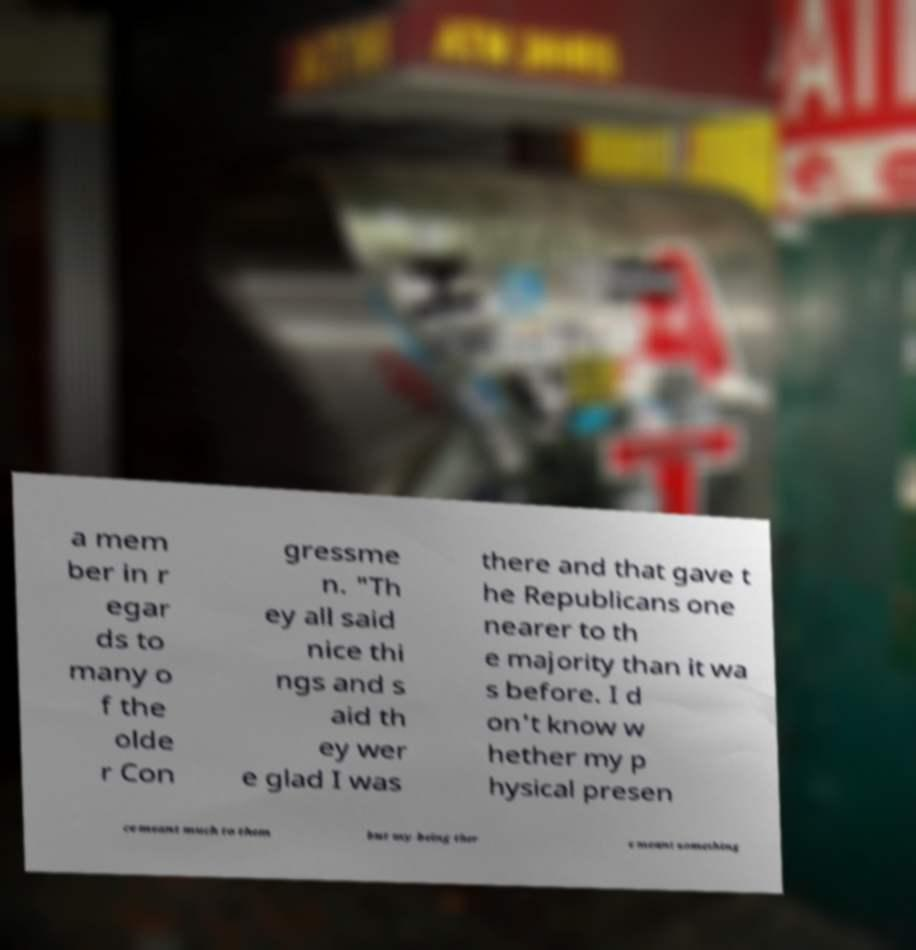Can you accurately transcribe the text from the provided image for me? a mem ber in r egar ds to many o f the olde r Con gressme n. "Th ey all said nice thi ngs and s aid th ey wer e glad I was there and that gave t he Republicans one nearer to th e majority than it wa s before. I d on't know w hether my p hysical presen ce meant much to them but my being ther e meant something 